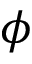<formula> <loc_0><loc_0><loc_500><loc_500>\phi</formula> 